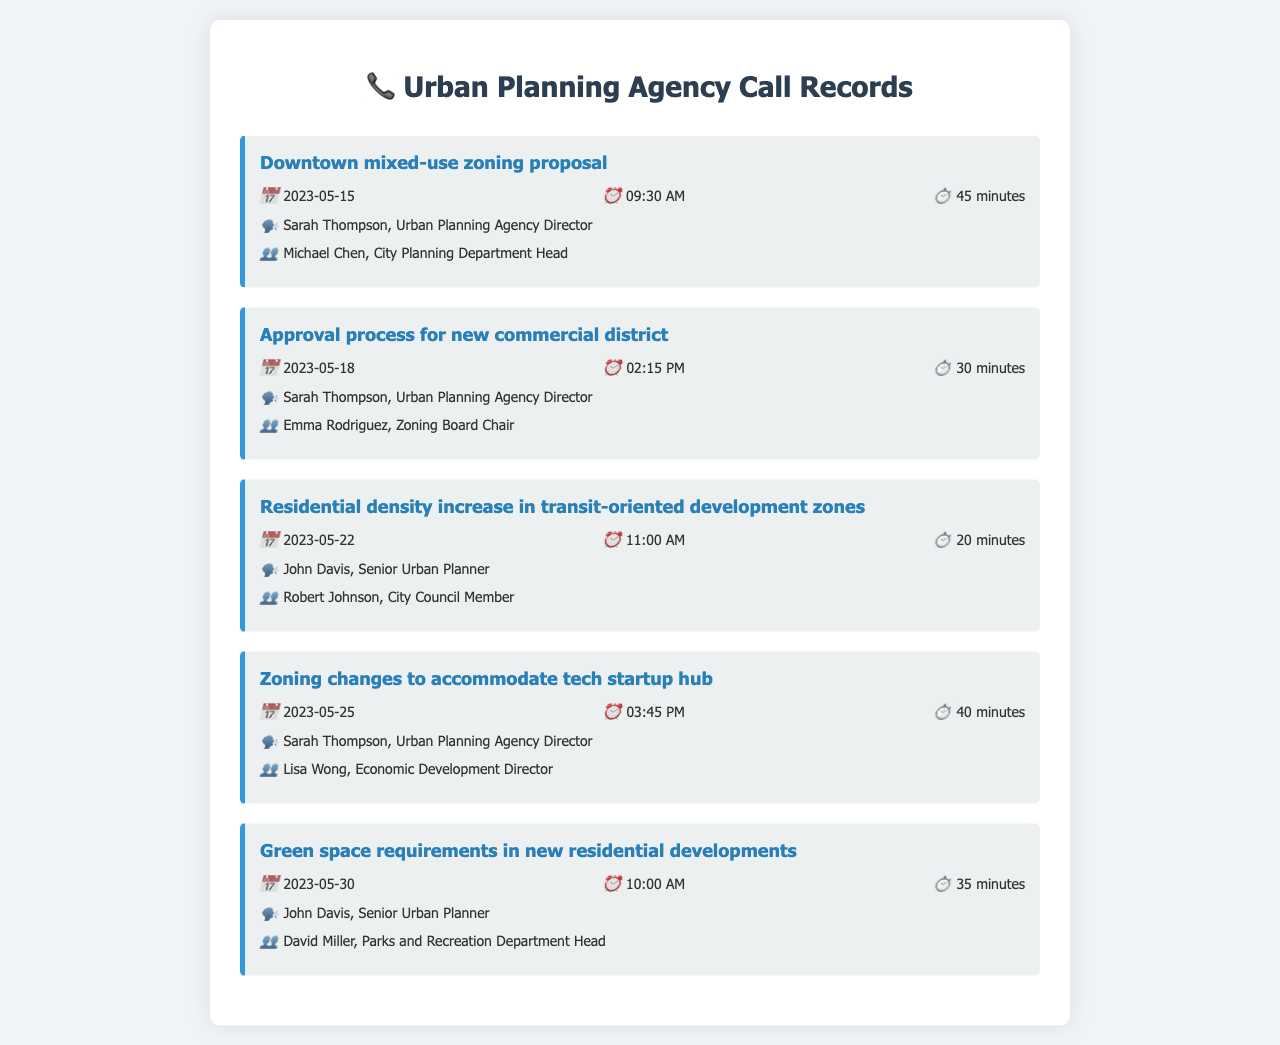What is the date of the call about the Downtown mixed-use zoning proposal? The call about the Downtown mixed-use zoning proposal occurred on May 15, 2023.
Answer: May 15, 2023 Who was involved in the call regarding the approval process for the new commercial district? The call involved Sarah Thompson from the Urban Planning Agency and Emma Rodriguez from the Zoning Board.
Answer: Sarah Thompson, Emma Rodriguez How long was the call regarding residential density increase? The call about residential density increase lasted 20 minutes.
Answer: 20 minutes What was the topic of the call on May 25, 2023? The topic of the call on that date was zoning changes to accommodate a tech startup hub.
Answer: Zoning changes to accommodate tech startup hub Which city official was present in the call about green space requirements? David Miller, the Parks and Recreation Department Head, was present in that call.
Answer: David Miller How many calls were documented on zoning changes? A total of three calls regarding zoning changes were documented.
Answer: Three Who was the Urban Planning Agency Director during these calls? Sarah Thompson was the Urban Planning Agency Director during these calls.
Answer: Sarah Thompson When did the conversation about residential density increase take place? The conversation about residential density increase took place on May 22, 2023.
Answer: May 22, 2023 